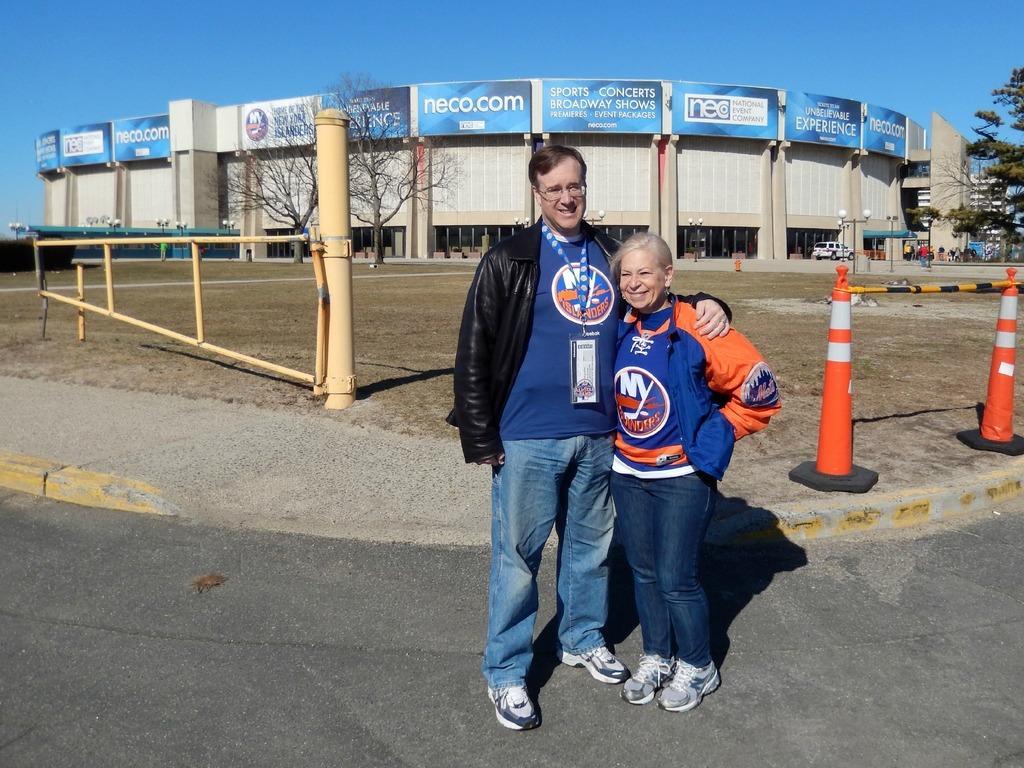Can you describe this image briefly? There is a man and a woman standing on the road and they are smiling. In the background we can see poles, trees, few persons, and a vehicle. In the background we can see a building, boards, and sky. 